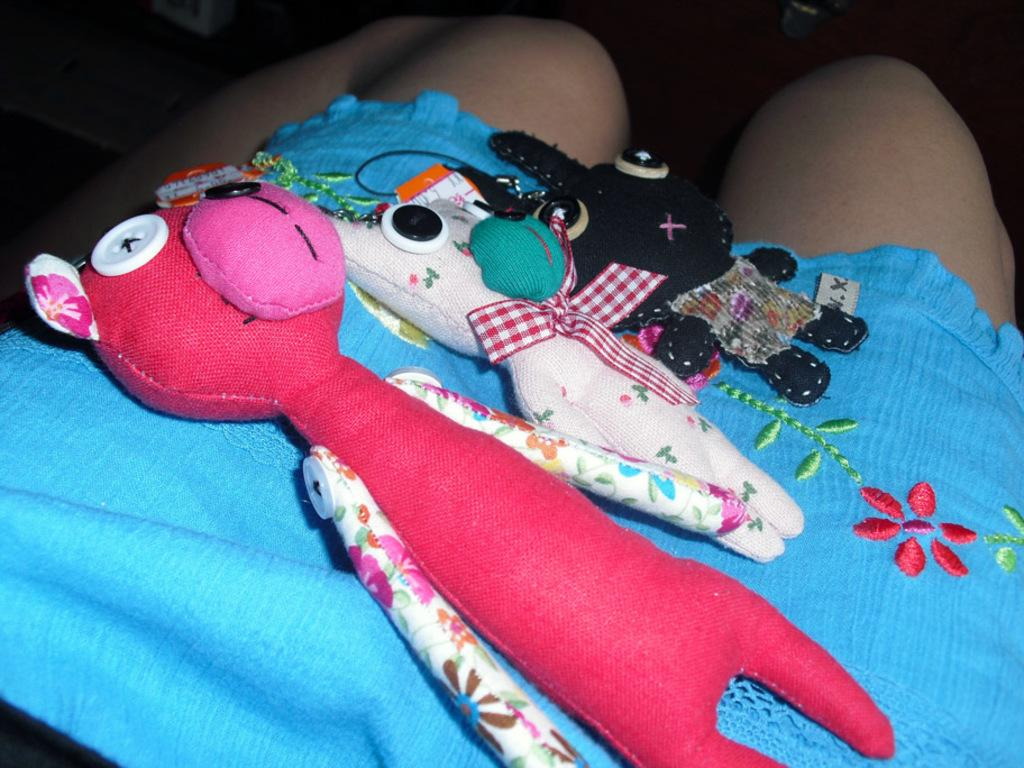How many soft toys are visible in the image? There are three soft toys in the image. Where are the soft toys placed? The soft toys are kept on a cloth. Can you describe the background of the image? The background of the image is blurred. What type of voice can be heard coming from the soft toys in the image? There is no voice coming from the soft toys in the image, as they are inanimate objects. 